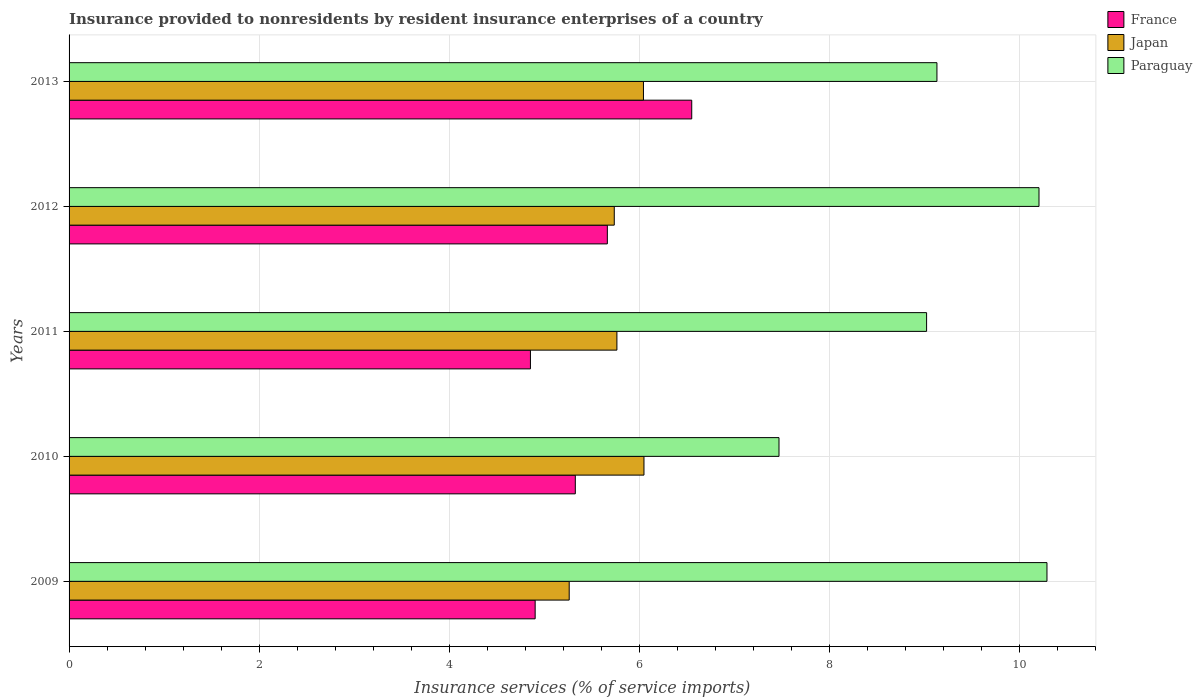How many different coloured bars are there?
Offer a very short reply. 3. How many groups of bars are there?
Give a very brief answer. 5. What is the insurance provided to nonresidents in France in 2013?
Your answer should be very brief. 6.55. Across all years, what is the maximum insurance provided to nonresidents in Paraguay?
Keep it short and to the point. 10.29. Across all years, what is the minimum insurance provided to nonresidents in France?
Keep it short and to the point. 4.85. In which year was the insurance provided to nonresidents in Paraguay minimum?
Offer a very short reply. 2010. What is the total insurance provided to nonresidents in France in the graph?
Offer a very short reply. 27.29. What is the difference between the insurance provided to nonresidents in France in 2009 and that in 2011?
Offer a terse response. 0.05. What is the difference between the insurance provided to nonresidents in Japan in 2011 and the insurance provided to nonresidents in France in 2013?
Your response must be concise. -0.79. What is the average insurance provided to nonresidents in Japan per year?
Your answer should be compact. 5.77. In the year 2011, what is the difference between the insurance provided to nonresidents in Paraguay and insurance provided to nonresidents in Japan?
Provide a succinct answer. 3.26. What is the ratio of the insurance provided to nonresidents in France in 2009 to that in 2012?
Give a very brief answer. 0.87. What is the difference between the highest and the second highest insurance provided to nonresidents in Paraguay?
Keep it short and to the point. 0.08. What is the difference between the highest and the lowest insurance provided to nonresidents in Paraguay?
Make the answer very short. 2.82. In how many years, is the insurance provided to nonresidents in Paraguay greater than the average insurance provided to nonresidents in Paraguay taken over all years?
Give a very brief answer. 2. What does the 1st bar from the top in 2012 represents?
Provide a succinct answer. Paraguay. What does the 1st bar from the bottom in 2011 represents?
Keep it short and to the point. France. How many bars are there?
Give a very brief answer. 15. How many years are there in the graph?
Your answer should be very brief. 5. What is the difference between two consecutive major ticks on the X-axis?
Offer a terse response. 2. Does the graph contain any zero values?
Keep it short and to the point. No. Does the graph contain grids?
Your answer should be compact. Yes. How many legend labels are there?
Your response must be concise. 3. What is the title of the graph?
Your answer should be very brief. Insurance provided to nonresidents by resident insurance enterprises of a country. Does "Argentina" appear as one of the legend labels in the graph?
Make the answer very short. No. What is the label or title of the X-axis?
Offer a very short reply. Insurance services (% of service imports). What is the Insurance services (% of service imports) of France in 2009?
Give a very brief answer. 4.9. What is the Insurance services (% of service imports) of Japan in 2009?
Provide a short and direct response. 5.26. What is the Insurance services (% of service imports) of Paraguay in 2009?
Provide a short and direct response. 10.29. What is the Insurance services (% of service imports) in France in 2010?
Your answer should be very brief. 5.32. What is the Insurance services (% of service imports) in Japan in 2010?
Ensure brevity in your answer.  6.05. What is the Insurance services (% of service imports) of Paraguay in 2010?
Provide a short and direct response. 7.47. What is the Insurance services (% of service imports) of France in 2011?
Provide a short and direct response. 4.85. What is the Insurance services (% of service imports) of Japan in 2011?
Your answer should be very brief. 5.76. What is the Insurance services (% of service imports) in Paraguay in 2011?
Offer a very short reply. 9.02. What is the Insurance services (% of service imports) of France in 2012?
Your answer should be very brief. 5.66. What is the Insurance services (% of service imports) of Japan in 2012?
Give a very brief answer. 5.73. What is the Insurance services (% of service imports) of Paraguay in 2012?
Your response must be concise. 10.2. What is the Insurance services (% of service imports) in France in 2013?
Make the answer very short. 6.55. What is the Insurance services (% of service imports) in Japan in 2013?
Make the answer very short. 6.04. What is the Insurance services (% of service imports) of Paraguay in 2013?
Give a very brief answer. 9.13. Across all years, what is the maximum Insurance services (% of service imports) in France?
Your answer should be compact. 6.55. Across all years, what is the maximum Insurance services (% of service imports) of Japan?
Provide a succinct answer. 6.05. Across all years, what is the maximum Insurance services (% of service imports) in Paraguay?
Your answer should be very brief. 10.29. Across all years, what is the minimum Insurance services (% of service imports) of France?
Your answer should be compact. 4.85. Across all years, what is the minimum Insurance services (% of service imports) in Japan?
Provide a succinct answer. 5.26. Across all years, what is the minimum Insurance services (% of service imports) in Paraguay?
Ensure brevity in your answer.  7.47. What is the total Insurance services (% of service imports) of France in the graph?
Provide a succinct answer. 27.29. What is the total Insurance services (% of service imports) of Japan in the graph?
Provide a succinct answer. 28.85. What is the total Insurance services (% of service imports) of Paraguay in the graph?
Give a very brief answer. 46.1. What is the difference between the Insurance services (% of service imports) of France in 2009 and that in 2010?
Provide a succinct answer. -0.42. What is the difference between the Insurance services (% of service imports) of Japan in 2009 and that in 2010?
Ensure brevity in your answer.  -0.79. What is the difference between the Insurance services (% of service imports) of Paraguay in 2009 and that in 2010?
Offer a terse response. 2.82. What is the difference between the Insurance services (% of service imports) of France in 2009 and that in 2011?
Offer a very short reply. 0.05. What is the difference between the Insurance services (% of service imports) in Japan in 2009 and that in 2011?
Offer a very short reply. -0.5. What is the difference between the Insurance services (% of service imports) of Paraguay in 2009 and that in 2011?
Provide a short and direct response. 1.27. What is the difference between the Insurance services (% of service imports) of France in 2009 and that in 2012?
Your answer should be very brief. -0.76. What is the difference between the Insurance services (% of service imports) in Japan in 2009 and that in 2012?
Make the answer very short. -0.47. What is the difference between the Insurance services (% of service imports) in Paraguay in 2009 and that in 2012?
Your response must be concise. 0.08. What is the difference between the Insurance services (% of service imports) of France in 2009 and that in 2013?
Provide a succinct answer. -1.65. What is the difference between the Insurance services (% of service imports) in Japan in 2009 and that in 2013?
Make the answer very short. -0.78. What is the difference between the Insurance services (% of service imports) of Paraguay in 2009 and that in 2013?
Provide a short and direct response. 1.16. What is the difference between the Insurance services (% of service imports) in France in 2010 and that in 2011?
Make the answer very short. 0.47. What is the difference between the Insurance services (% of service imports) of Japan in 2010 and that in 2011?
Offer a very short reply. 0.28. What is the difference between the Insurance services (% of service imports) in Paraguay in 2010 and that in 2011?
Offer a terse response. -1.55. What is the difference between the Insurance services (% of service imports) of France in 2010 and that in 2012?
Your response must be concise. -0.34. What is the difference between the Insurance services (% of service imports) of Japan in 2010 and that in 2012?
Offer a very short reply. 0.31. What is the difference between the Insurance services (% of service imports) of Paraguay in 2010 and that in 2012?
Your answer should be very brief. -2.73. What is the difference between the Insurance services (% of service imports) of France in 2010 and that in 2013?
Give a very brief answer. -1.22. What is the difference between the Insurance services (% of service imports) in Japan in 2010 and that in 2013?
Ensure brevity in your answer.  0.01. What is the difference between the Insurance services (% of service imports) of Paraguay in 2010 and that in 2013?
Ensure brevity in your answer.  -1.66. What is the difference between the Insurance services (% of service imports) of France in 2011 and that in 2012?
Your response must be concise. -0.81. What is the difference between the Insurance services (% of service imports) of Japan in 2011 and that in 2012?
Your response must be concise. 0.03. What is the difference between the Insurance services (% of service imports) of Paraguay in 2011 and that in 2012?
Keep it short and to the point. -1.18. What is the difference between the Insurance services (% of service imports) of France in 2011 and that in 2013?
Offer a terse response. -1.7. What is the difference between the Insurance services (% of service imports) in Japan in 2011 and that in 2013?
Keep it short and to the point. -0.28. What is the difference between the Insurance services (% of service imports) of Paraguay in 2011 and that in 2013?
Offer a very short reply. -0.11. What is the difference between the Insurance services (% of service imports) in France in 2012 and that in 2013?
Give a very brief answer. -0.89. What is the difference between the Insurance services (% of service imports) in Japan in 2012 and that in 2013?
Make the answer very short. -0.31. What is the difference between the Insurance services (% of service imports) in Paraguay in 2012 and that in 2013?
Ensure brevity in your answer.  1.07. What is the difference between the Insurance services (% of service imports) of France in 2009 and the Insurance services (% of service imports) of Japan in 2010?
Make the answer very short. -1.14. What is the difference between the Insurance services (% of service imports) of France in 2009 and the Insurance services (% of service imports) of Paraguay in 2010?
Your answer should be compact. -2.56. What is the difference between the Insurance services (% of service imports) of Japan in 2009 and the Insurance services (% of service imports) of Paraguay in 2010?
Ensure brevity in your answer.  -2.21. What is the difference between the Insurance services (% of service imports) of France in 2009 and the Insurance services (% of service imports) of Japan in 2011?
Give a very brief answer. -0.86. What is the difference between the Insurance services (% of service imports) in France in 2009 and the Insurance services (% of service imports) in Paraguay in 2011?
Provide a succinct answer. -4.12. What is the difference between the Insurance services (% of service imports) in Japan in 2009 and the Insurance services (% of service imports) in Paraguay in 2011?
Your response must be concise. -3.76. What is the difference between the Insurance services (% of service imports) of France in 2009 and the Insurance services (% of service imports) of Japan in 2012?
Keep it short and to the point. -0.83. What is the difference between the Insurance services (% of service imports) in France in 2009 and the Insurance services (% of service imports) in Paraguay in 2012?
Offer a very short reply. -5.3. What is the difference between the Insurance services (% of service imports) in Japan in 2009 and the Insurance services (% of service imports) in Paraguay in 2012?
Your response must be concise. -4.94. What is the difference between the Insurance services (% of service imports) in France in 2009 and the Insurance services (% of service imports) in Japan in 2013?
Your response must be concise. -1.14. What is the difference between the Insurance services (% of service imports) in France in 2009 and the Insurance services (% of service imports) in Paraguay in 2013?
Offer a very short reply. -4.23. What is the difference between the Insurance services (% of service imports) of Japan in 2009 and the Insurance services (% of service imports) of Paraguay in 2013?
Offer a very short reply. -3.87. What is the difference between the Insurance services (% of service imports) in France in 2010 and the Insurance services (% of service imports) in Japan in 2011?
Your response must be concise. -0.44. What is the difference between the Insurance services (% of service imports) of France in 2010 and the Insurance services (% of service imports) of Paraguay in 2011?
Make the answer very short. -3.69. What is the difference between the Insurance services (% of service imports) in Japan in 2010 and the Insurance services (% of service imports) in Paraguay in 2011?
Provide a short and direct response. -2.97. What is the difference between the Insurance services (% of service imports) of France in 2010 and the Insurance services (% of service imports) of Japan in 2012?
Make the answer very short. -0.41. What is the difference between the Insurance services (% of service imports) in France in 2010 and the Insurance services (% of service imports) in Paraguay in 2012?
Ensure brevity in your answer.  -4.88. What is the difference between the Insurance services (% of service imports) in Japan in 2010 and the Insurance services (% of service imports) in Paraguay in 2012?
Provide a short and direct response. -4.16. What is the difference between the Insurance services (% of service imports) of France in 2010 and the Insurance services (% of service imports) of Japan in 2013?
Provide a succinct answer. -0.72. What is the difference between the Insurance services (% of service imports) of France in 2010 and the Insurance services (% of service imports) of Paraguay in 2013?
Your response must be concise. -3.8. What is the difference between the Insurance services (% of service imports) of Japan in 2010 and the Insurance services (% of service imports) of Paraguay in 2013?
Make the answer very short. -3.08. What is the difference between the Insurance services (% of service imports) of France in 2011 and the Insurance services (% of service imports) of Japan in 2012?
Give a very brief answer. -0.88. What is the difference between the Insurance services (% of service imports) of France in 2011 and the Insurance services (% of service imports) of Paraguay in 2012?
Offer a terse response. -5.35. What is the difference between the Insurance services (% of service imports) in Japan in 2011 and the Insurance services (% of service imports) in Paraguay in 2012?
Provide a short and direct response. -4.44. What is the difference between the Insurance services (% of service imports) in France in 2011 and the Insurance services (% of service imports) in Japan in 2013?
Your answer should be compact. -1.19. What is the difference between the Insurance services (% of service imports) in France in 2011 and the Insurance services (% of service imports) in Paraguay in 2013?
Provide a short and direct response. -4.28. What is the difference between the Insurance services (% of service imports) of Japan in 2011 and the Insurance services (% of service imports) of Paraguay in 2013?
Ensure brevity in your answer.  -3.37. What is the difference between the Insurance services (% of service imports) of France in 2012 and the Insurance services (% of service imports) of Japan in 2013?
Your response must be concise. -0.38. What is the difference between the Insurance services (% of service imports) in France in 2012 and the Insurance services (% of service imports) in Paraguay in 2013?
Provide a succinct answer. -3.47. What is the difference between the Insurance services (% of service imports) in Japan in 2012 and the Insurance services (% of service imports) in Paraguay in 2013?
Offer a terse response. -3.39. What is the average Insurance services (% of service imports) in France per year?
Your answer should be compact. 5.46. What is the average Insurance services (% of service imports) in Japan per year?
Provide a succinct answer. 5.77. What is the average Insurance services (% of service imports) in Paraguay per year?
Offer a terse response. 9.22. In the year 2009, what is the difference between the Insurance services (% of service imports) of France and Insurance services (% of service imports) of Japan?
Ensure brevity in your answer.  -0.36. In the year 2009, what is the difference between the Insurance services (% of service imports) of France and Insurance services (% of service imports) of Paraguay?
Your answer should be very brief. -5.38. In the year 2009, what is the difference between the Insurance services (% of service imports) of Japan and Insurance services (% of service imports) of Paraguay?
Give a very brief answer. -5.03. In the year 2010, what is the difference between the Insurance services (% of service imports) in France and Insurance services (% of service imports) in Japan?
Give a very brief answer. -0.72. In the year 2010, what is the difference between the Insurance services (% of service imports) of France and Insurance services (% of service imports) of Paraguay?
Your response must be concise. -2.14. In the year 2010, what is the difference between the Insurance services (% of service imports) of Japan and Insurance services (% of service imports) of Paraguay?
Your response must be concise. -1.42. In the year 2011, what is the difference between the Insurance services (% of service imports) of France and Insurance services (% of service imports) of Japan?
Provide a short and direct response. -0.91. In the year 2011, what is the difference between the Insurance services (% of service imports) in France and Insurance services (% of service imports) in Paraguay?
Your answer should be compact. -4.17. In the year 2011, what is the difference between the Insurance services (% of service imports) of Japan and Insurance services (% of service imports) of Paraguay?
Your response must be concise. -3.26. In the year 2012, what is the difference between the Insurance services (% of service imports) in France and Insurance services (% of service imports) in Japan?
Ensure brevity in your answer.  -0.07. In the year 2012, what is the difference between the Insurance services (% of service imports) of France and Insurance services (% of service imports) of Paraguay?
Ensure brevity in your answer.  -4.54. In the year 2012, what is the difference between the Insurance services (% of service imports) in Japan and Insurance services (% of service imports) in Paraguay?
Offer a terse response. -4.47. In the year 2013, what is the difference between the Insurance services (% of service imports) in France and Insurance services (% of service imports) in Japan?
Give a very brief answer. 0.51. In the year 2013, what is the difference between the Insurance services (% of service imports) in France and Insurance services (% of service imports) in Paraguay?
Keep it short and to the point. -2.58. In the year 2013, what is the difference between the Insurance services (% of service imports) of Japan and Insurance services (% of service imports) of Paraguay?
Offer a very short reply. -3.09. What is the ratio of the Insurance services (% of service imports) of France in 2009 to that in 2010?
Your response must be concise. 0.92. What is the ratio of the Insurance services (% of service imports) in Japan in 2009 to that in 2010?
Make the answer very short. 0.87. What is the ratio of the Insurance services (% of service imports) in Paraguay in 2009 to that in 2010?
Offer a terse response. 1.38. What is the ratio of the Insurance services (% of service imports) of France in 2009 to that in 2011?
Your answer should be very brief. 1.01. What is the ratio of the Insurance services (% of service imports) of Japan in 2009 to that in 2011?
Offer a very short reply. 0.91. What is the ratio of the Insurance services (% of service imports) of Paraguay in 2009 to that in 2011?
Ensure brevity in your answer.  1.14. What is the ratio of the Insurance services (% of service imports) in France in 2009 to that in 2012?
Provide a succinct answer. 0.87. What is the ratio of the Insurance services (% of service imports) of Japan in 2009 to that in 2012?
Ensure brevity in your answer.  0.92. What is the ratio of the Insurance services (% of service imports) of Paraguay in 2009 to that in 2012?
Provide a short and direct response. 1.01. What is the ratio of the Insurance services (% of service imports) of France in 2009 to that in 2013?
Provide a short and direct response. 0.75. What is the ratio of the Insurance services (% of service imports) of Japan in 2009 to that in 2013?
Your answer should be very brief. 0.87. What is the ratio of the Insurance services (% of service imports) in Paraguay in 2009 to that in 2013?
Offer a very short reply. 1.13. What is the ratio of the Insurance services (% of service imports) of France in 2010 to that in 2011?
Give a very brief answer. 1.1. What is the ratio of the Insurance services (% of service imports) of Japan in 2010 to that in 2011?
Make the answer very short. 1.05. What is the ratio of the Insurance services (% of service imports) of Paraguay in 2010 to that in 2011?
Your answer should be compact. 0.83. What is the ratio of the Insurance services (% of service imports) in France in 2010 to that in 2012?
Offer a terse response. 0.94. What is the ratio of the Insurance services (% of service imports) of Japan in 2010 to that in 2012?
Provide a short and direct response. 1.05. What is the ratio of the Insurance services (% of service imports) of Paraguay in 2010 to that in 2012?
Offer a terse response. 0.73. What is the ratio of the Insurance services (% of service imports) in France in 2010 to that in 2013?
Provide a succinct answer. 0.81. What is the ratio of the Insurance services (% of service imports) of Paraguay in 2010 to that in 2013?
Your answer should be very brief. 0.82. What is the ratio of the Insurance services (% of service imports) in Paraguay in 2011 to that in 2012?
Provide a short and direct response. 0.88. What is the ratio of the Insurance services (% of service imports) of France in 2011 to that in 2013?
Keep it short and to the point. 0.74. What is the ratio of the Insurance services (% of service imports) of Japan in 2011 to that in 2013?
Ensure brevity in your answer.  0.95. What is the ratio of the Insurance services (% of service imports) in Paraguay in 2011 to that in 2013?
Your response must be concise. 0.99. What is the ratio of the Insurance services (% of service imports) in France in 2012 to that in 2013?
Your answer should be very brief. 0.86. What is the ratio of the Insurance services (% of service imports) in Japan in 2012 to that in 2013?
Your answer should be compact. 0.95. What is the ratio of the Insurance services (% of service imports) in Paraguay in 2012 to that in 2013?
Offer a terse response. 1.12. What is the difference between the highest and the second highest Insurance services (% of service imports) in France?
Provide a short and direct response. 0.89. What is the difference between the highest and the second highest Insurance services (% of service imports) of Japan?
Offer a terse response. 0.01. What is the difference between the highest and the second highest Insurance services (% of service imports) of Paraguay?
Provide a succinct answer. 0.08. What is the difference between the highest and the lowest Insurance services (% of service imports) in France?
Offer a terse response. 1.7. What is the difference between the highest and the lowest Insurance services (% of service imports) in Japan?
Keep it short and to the point. 0.79. What is the difference between the highest and the lowest Insurance services (% of service imports) of Paraguay?
Offer a terse response. 2.82. 